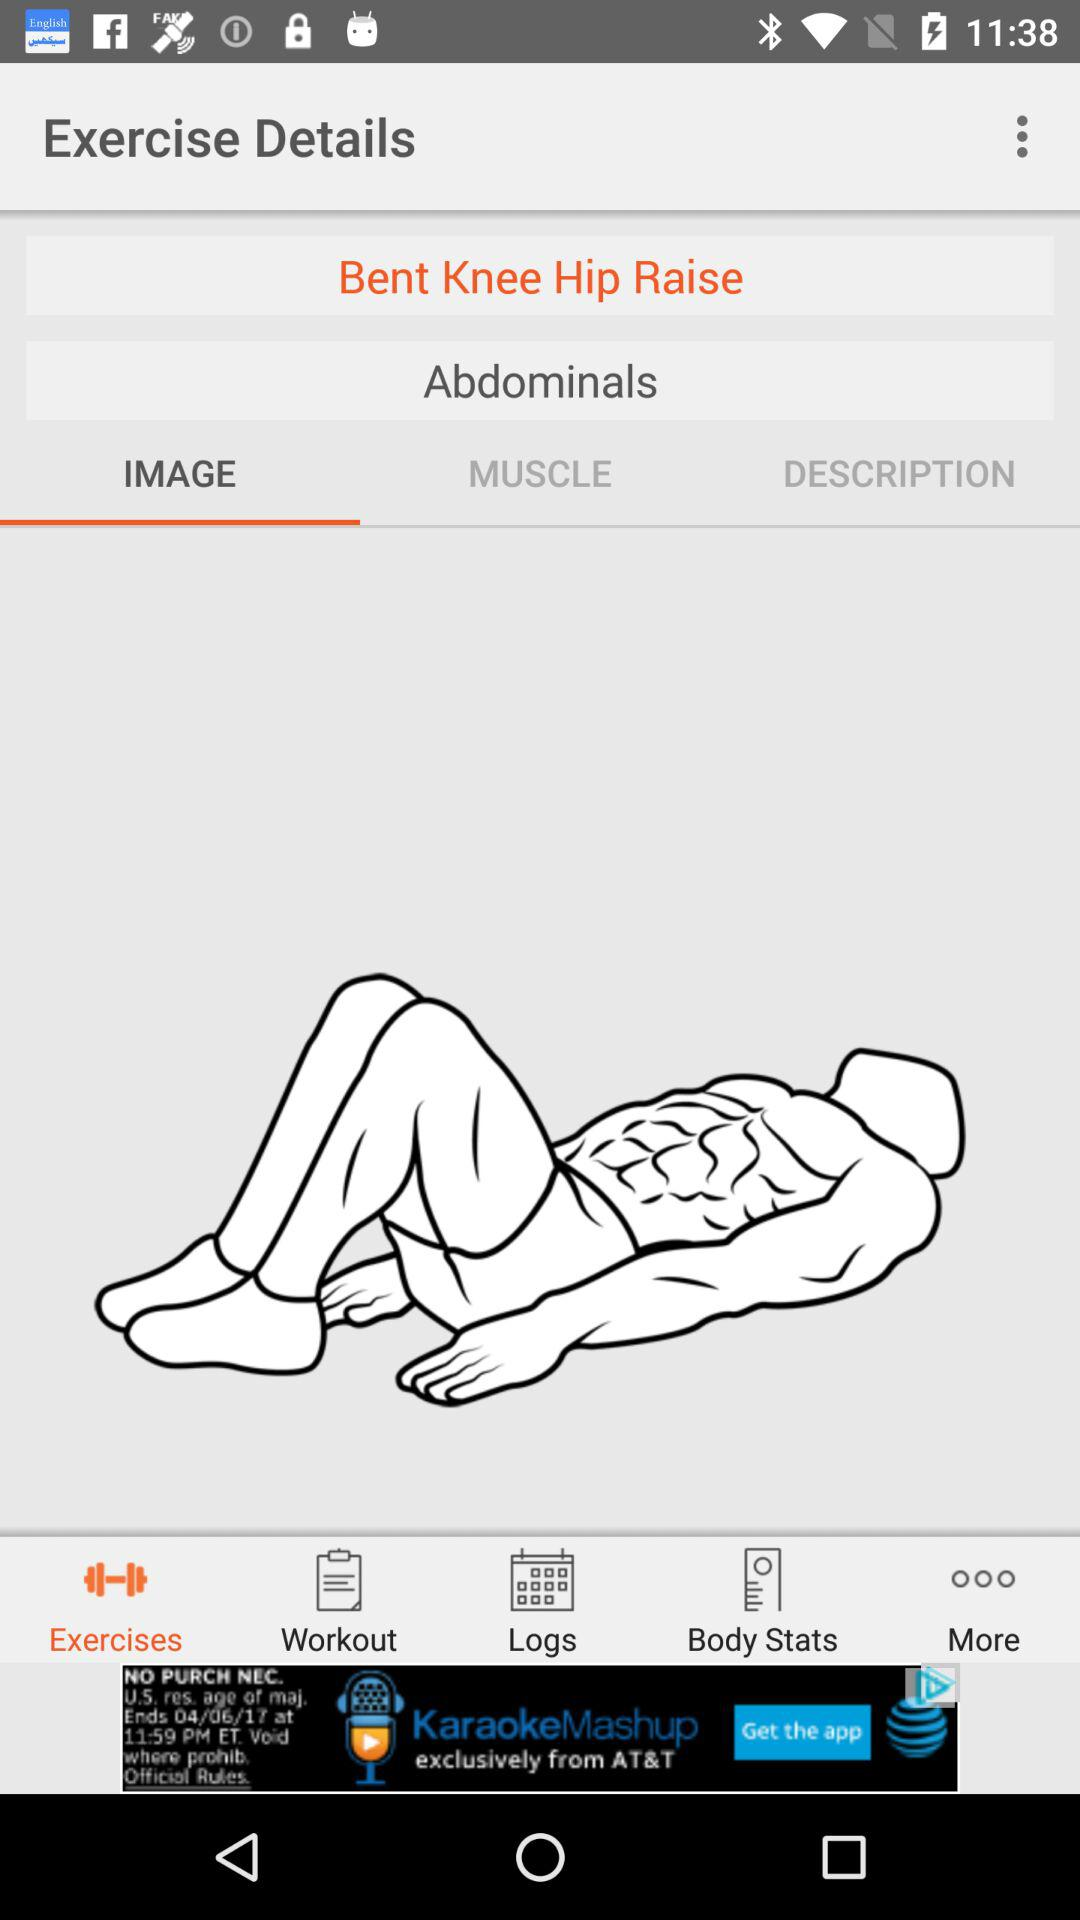Which tab is selected? The selected tabs are "Exercises" and "IMAGE". 